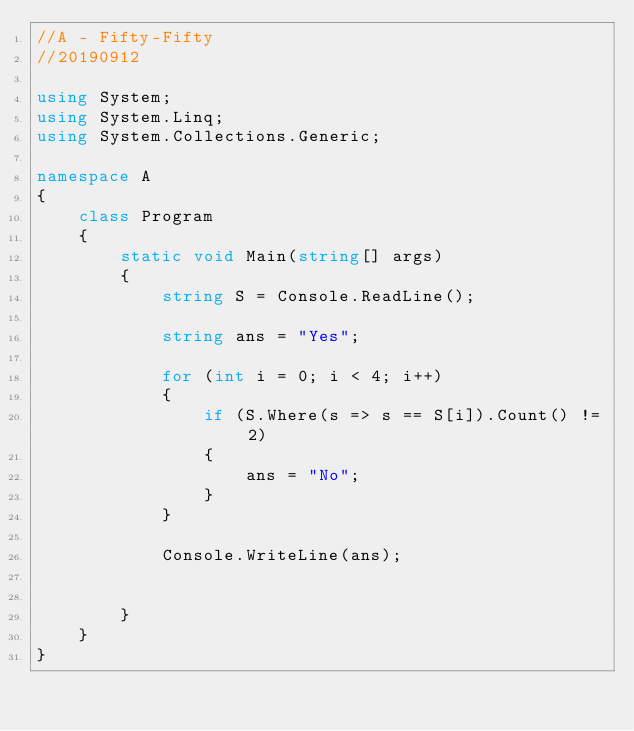<code> <loc_0><loc_0><loc_500><loc_500><_C#_>//A - Fifty-Fifty
//20190912

using System;
using System.Linq;
using System.Collections.Generic;

namespace A
{
    class Program
    {
        static void Main(string[] args)
        {
            string S = Console.ReadLine();

            string ans = "Yes";

            for (int i = 0; i < 4; i++)
            {
                if (S.Where(s => s == S[i]).Count() != 2)
                {
                    ans = "No";
                }
            }

            Console.WriteLine(ans);


        }
    }
}
</code> 